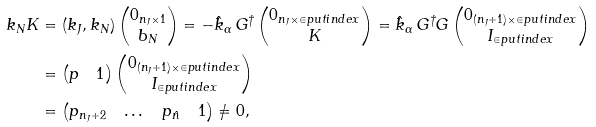<formula> <loc_0><loc_0><loc_500><loc_500>k _ { N } K & = ( k _ { J } , k _ { N } ) \begin{pmatrix} 0 _ { n _ { J } \times 1 } \\ b _ { N } \end{pmatrix} = - \hat { k } _ { \alpha } \, G ^ { \dagger } \begin{pmatrix} 0 _ { n _ { J } \times \in p u t i n d e x } \\ K \end{pmatrix} = \hat { k } _ { \alpha } \, G ^ { \dagger } G \begin{pmatrix} 0 _ { ( n _ { J } + 1 ) \times \in p u t i n d e x } \\ I _ { \in p u t i n d e x } \end{pmatrix} \\ & = \begin{pmatrix} p & 1 \end{pmatrix} \begin{pmatrix} 0 _ { ( n _ { J } + 1 ) \times \in p u t i n d e x } \\ I _ { \in p u t i n d e x } \end{pmatrix} \\ & = \begin{pmatrix} p _ { n _ { J } + 2 } & \dots & p _ { \hat { n } } & 1 \end{pmatrix} \neq 0 ,</formula> 